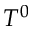<formula> <loc_0><loc_0><loc_500><loc_500>T ^ { 0 }</formula> 